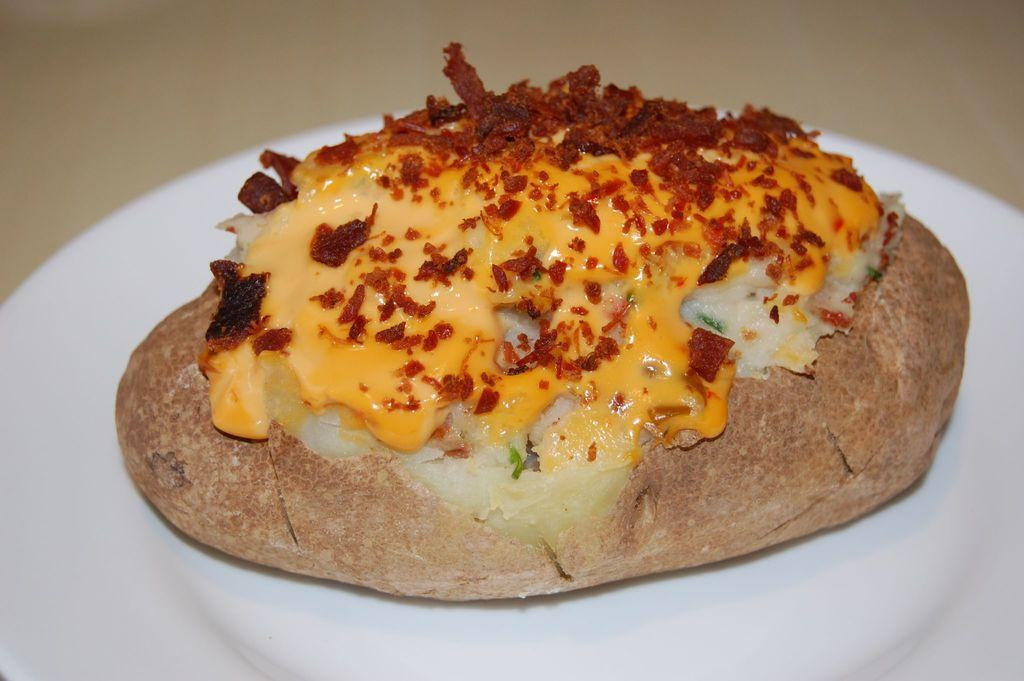What is present on the plate in the image? There is food in a plate in the image. Can you describe the type of food on the plate? The provided facts do not specify the type of food on the plate. Is there any cutlery or utensils visible in the image? The provided facts do not mention any cutlery or utensils. What is the zinc content of the food on the plate? The provided facts do not mention the zinc content of the food on the plate. What idea does the food on the plate represent? The provided facts do not mention any ideas or symbolism associated with the food on the plate. 